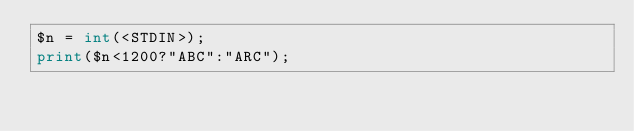Convert code to text. <code><loc_0><loc_0><loc_500><loc_500><_Perl_>$n = int(<STDIN>);
print($n<1200?"ABC":"ARC");</code> 